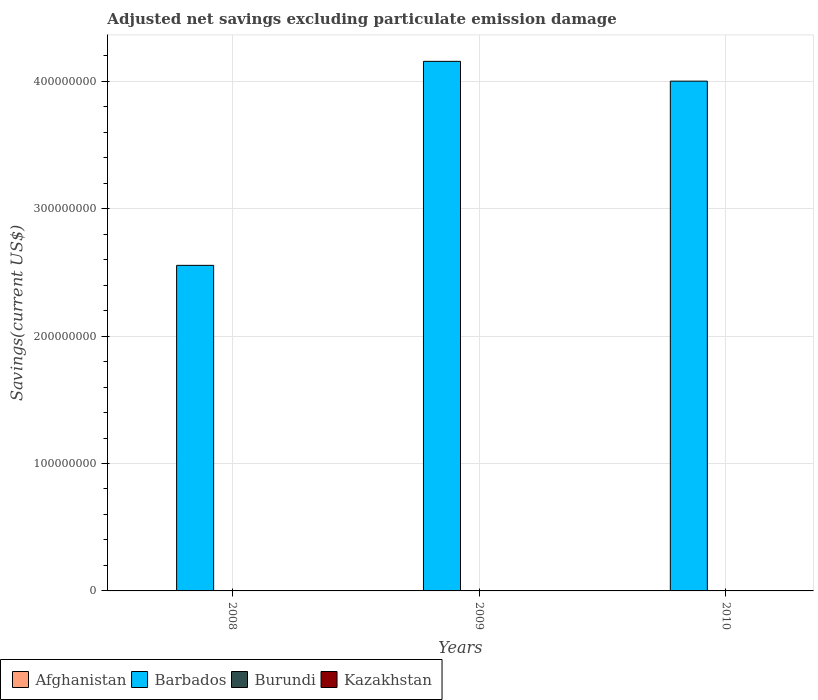Are the number of bars per tick equal to the number of legend labels?
Provide a succinct answer. No. How many bars are there on the 3rd tick from the right?
Offer a terse response. 1. What is the label of the 1st group of bars from the left?
Ensure brevity in your answer.  2008. What is the adjusted net savings in Barbados in 2008?
Your response must be concise. 2.56e+08. In which year was the adjusted net savings in Barbados maximum?
Make the answer very short. 2009. What is the average adjusted net savings in Barbados per year?
Your answer should be compact. 3.57e+08. In how many years, is the adjusted net savings in Barbados greater than 320000000 US$?
Offer a terse response. 2. What is the ratio of the adjusted net savings in Barbados in 2008 to that in 2010?
Provide a short and direct response. 0.64. What is the difference between the highest and the second highest adjusted net savings in Barbados?
Your answer should be compact. 1.55e+07. What is the difference between the highest and the lowest adjusted net savings in Barbados?
Ensure brevity in your answer.  1.60e+08. In how many years, is the adjusted net savings in Afghanistan greater than the average adjusted net savings in Afghanistan taken over all years?
Give a very brief answer. 0. Is it the case that in every year, the sum of the adjusted net savings in Afghanistan and adjusted net savings in Kazakhstan is greater than the sum of adjusted net savings in Burundi and adjusted net savings in Barbados?
Provide a succinct answer. No. How many bars are there?
Provide a succinct answer. 3. Are all the bars in the graph horizontal?
Keep it short and to the point. No. How many years are there in the graph?
Your response must be concise. 3. Are the values on the major ticks of Y-axis written in scientific E-notation?
Provide a succinct answer. No. Does the graph contain any zero values?
Provide a succinct answer. Yes. Does the graph contain grids?
Your answer should be compact. Yes. Where does the legend appear in the graph?
Make the answer very short. Bottom left. How many legend labels are there?
Provide a short and direct response. 4. How are the legend labels stacked?
Offer a terse response. Horizontal. What is the title of the graph?
Ensure brevity in your answer.  Adjusted net savings excluding particulate emission damage. Does "India" appear as one of the legend labels in the graph?
Offer a terse response. No. What is the label or title of the X-axis?
Provide a short and direct response. Years. What is the label or title of the Y-axis?
Provide a succinct answer. Savings(current US$). What is the Savings(current US$) in Barbados in 2008?
Give a very brief answer. 2.56e+08. What is the Savings(current US$) of Afghanistan in 2009?
Provide a short and direct response. 0. What is the Savings(current US$) in Barbados in 2009?
Keep it short and to the point. 4.16e+08. What is the Savings(current US$) of Burundi in 2009?
Provide a short and direct response. 0. What is the Savings(current US$) in Kazakhstan in 2009?
Provide a succinct answer. 0. What is the Savings(current US$) of Barbados in 2010?
Make the answer very short. 4.00e+08. Across all years, what is the maximum Savings(current US$) in Barbados?
Your answer should be compact. 4.16e+08. Across all years, what is the minimum Savings(current US$) of Barbados?
Offer a very short reply. 2.56e+08. What is the total Savings(current US$) in Barbados in the graph?
Your answer should be compact. 1.07e+09. What is the difference between the Savings(current US$) in Barbados in 2008 and that in 2009?
Your response must be concise. -1.60e+08. What is the difference between the Savings(current US$) in Barbados in 2008 and that in 2010?
Give a very brief answer. -1.45e+08. What is the difference between the Savings(current US$) in Barbados in 2009 and that in 2010?
Offer a terse response. 1.55e+07. What is the average Savings(current US$) of Barbados per year?
Provide a short and direct response. 3.57e+08. What is the average Savings(current US$) of Burundi per year?
Provide a short and direct response. 0. What is the ratio of the Savings(current US$) in Barbados in 2008 to that in 2009?
Your response must be concise. 0.61. What is the ratio of the Savings(current US$) in Barbados in 2008 to that in 2010?
Your answer should be very brief. 0.64. What is the ratio of the Savings(current US$) of Barbados in 2009 to that in 2010?
Ensure brevity in your answer.  1.04. What is the difference between the highest and the second highest Savings(current US$) of Barbados?
Offer a very short reply. 1.55e+07. What is the difference between the highest and the lowest Savings(current US$) of Barbados?
Your response must be concise. 1.60e+08. 